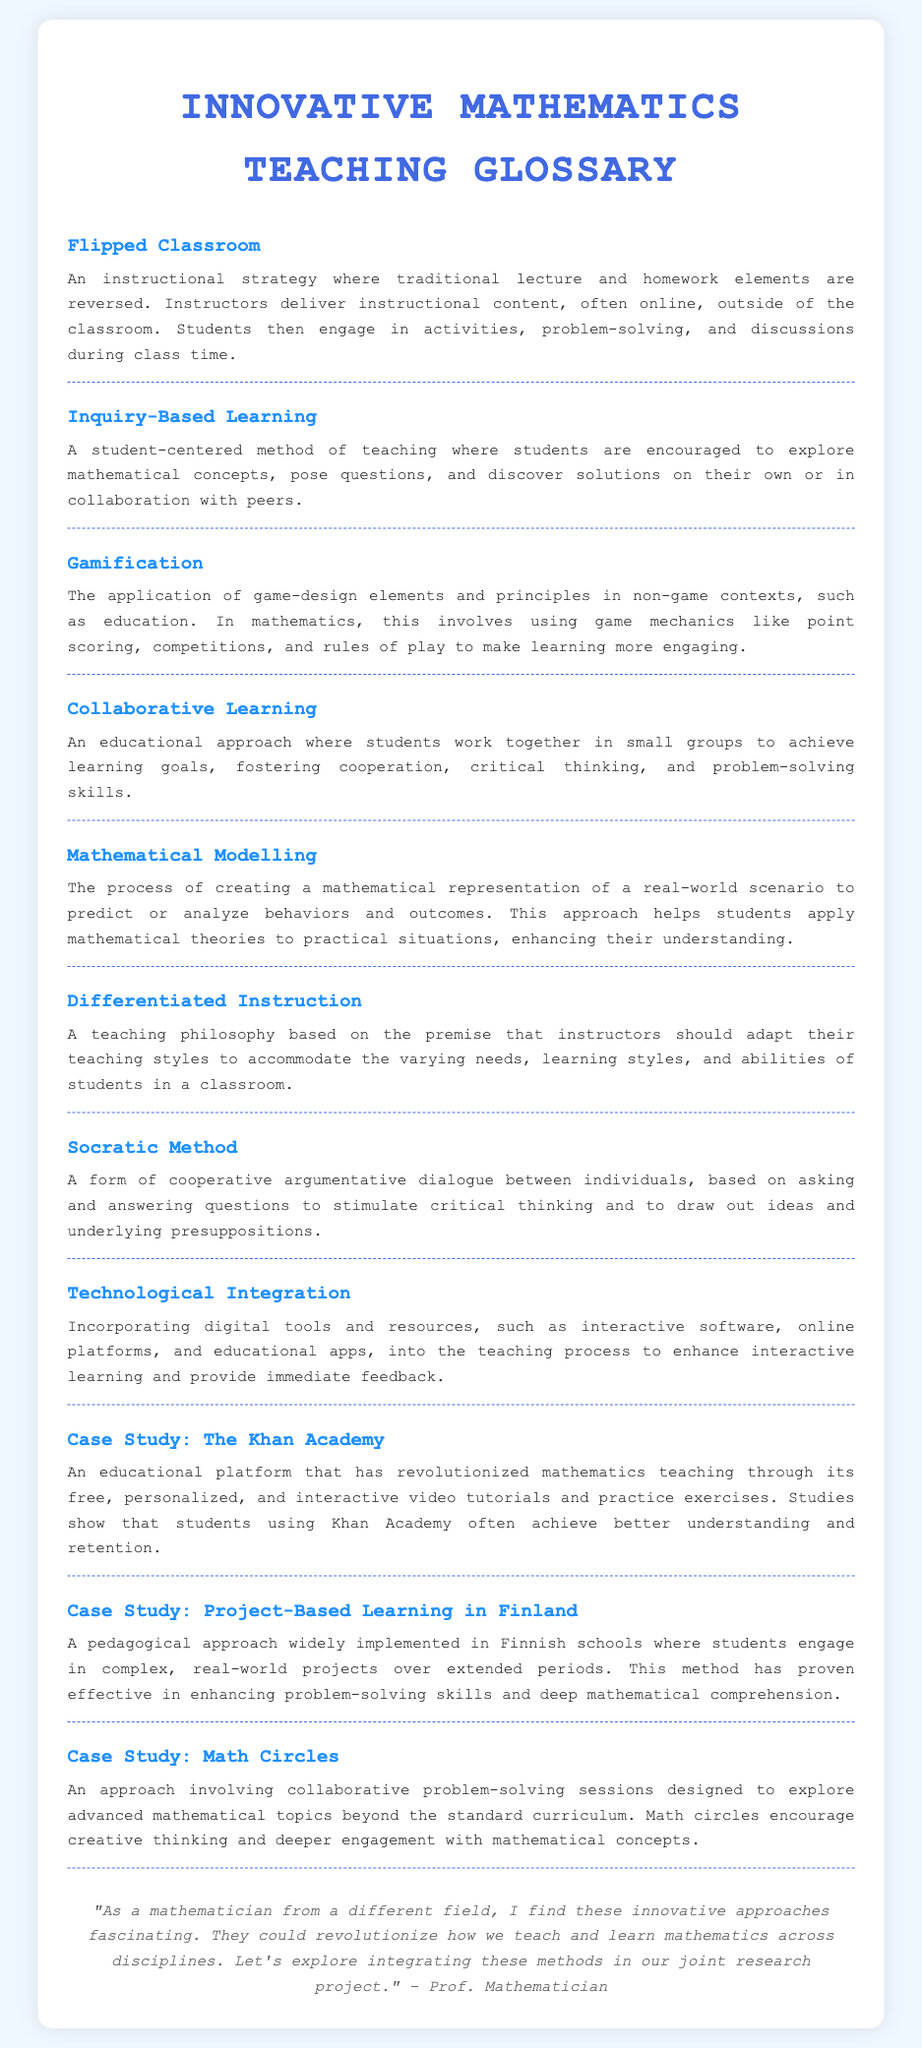What is the first term in the glossary? The first term listed in the glossary is the initial entry in the document, focused on a specific instructional strategy.
Answer: Flipped Classroom How many case studies are mentioned in the glossary? The document lists three specific case studies that illustrate innovative teaching techniques in mathematics.
Answer: Three What teaching method is characterized by questioning and dialogue? This method involves cooperative questioning to enhance critical thinking among students in a mathematical context.
Answer: Socratic Method What does the term "Gamification" refer to? "Gamification" describes the application of game-design elements in non-game contexts like educational settings to enhance engagement.
Answer: Game-design elements Which country is associated with the second case study? The second case study discusses a pedagogical approach that is widely implemented in schools of a specific country known for its education system.
Answer: Finland What is the primary focus of Mathematical Modelling? The foundational concept of Mathematical Modelling is to create representations of real-world scenarios to analyze and predict behaviors.
Answer: Real-world scenarios What does "Differentiated Instruction" accommodate? Differentiated Instruction is designed to accommodate the varying needs, learning styles, and abilities of students.
Answer: Varying needs What is the goal of Collaborative Learning? The goal of Collaborative Learning is to achieve learning objectives through group work, which fosters specific skills among students.
Answer: Learning goals 